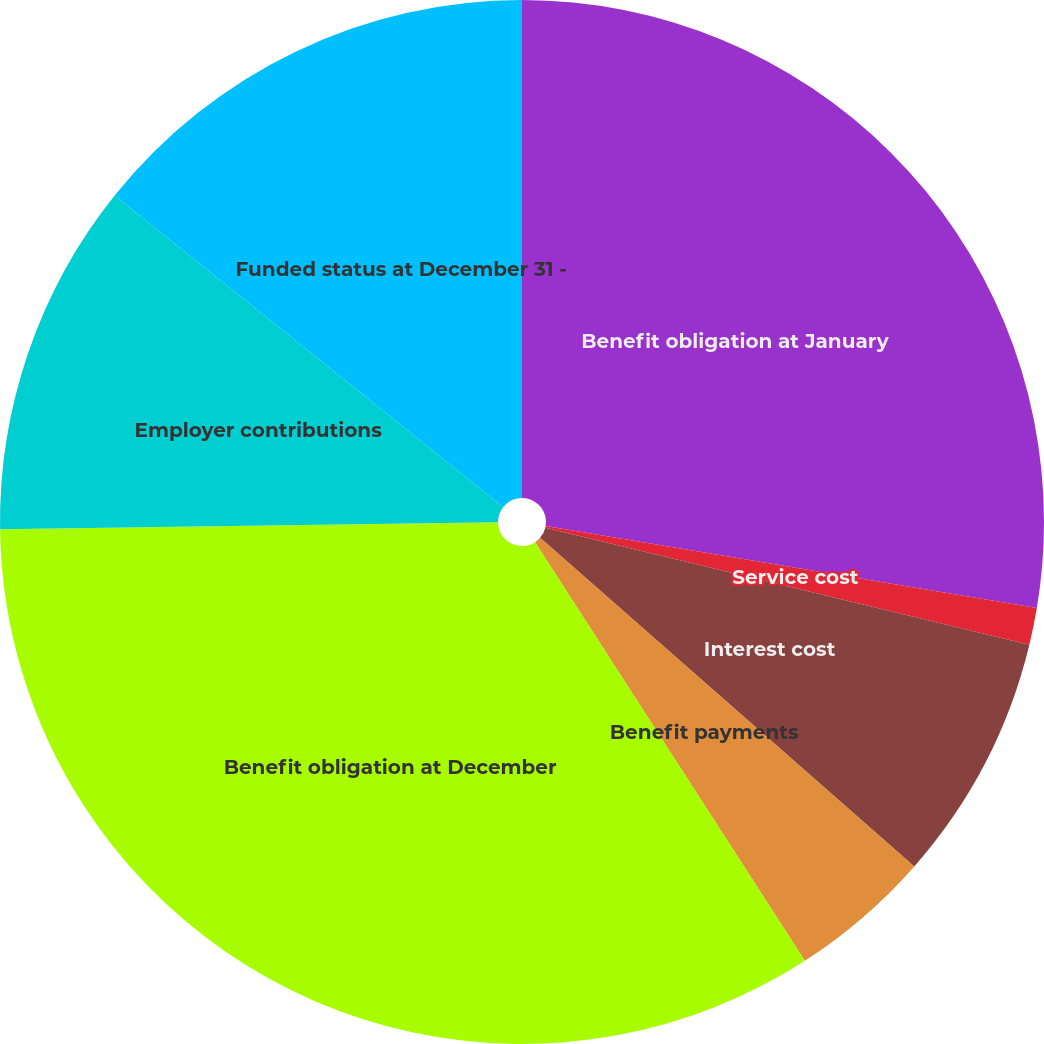Convert chart. <chart><loc_0><loc_0><loc_500><loc_500><pie_chart><fcel>Benefit obligation at January<fcel>Service cost<fcel>Interest cost<fcel>Benefit payments<fcel>Benefit obligation at December<fcel>Employer contributions<fcel>Funded status at December 31 -<nl><fcel>27.64%<fcel>1.14%<fcel>7.69%<fcel>4.42%<fcel>33.9%<fcel>10.97%<fcel>14.25%<nl></chart> 